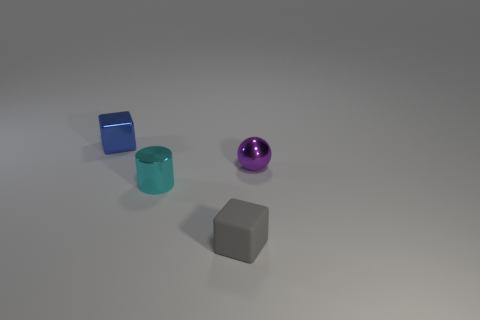Add 4 tiny cyan shiny things. How many objects exist? 8 Subtract 0 purple blocks. How many objects are left? 4 Subtract all spheres. How many objects are left? 3 Subtract all small blue things. Subtract all cyan cylinders. How many objects are left? 2 Add 1 gray rubber objects. How many gray rubber objects are left? 2 Add 2 large gray metallic things. How many large gray metallic things exist? 2 